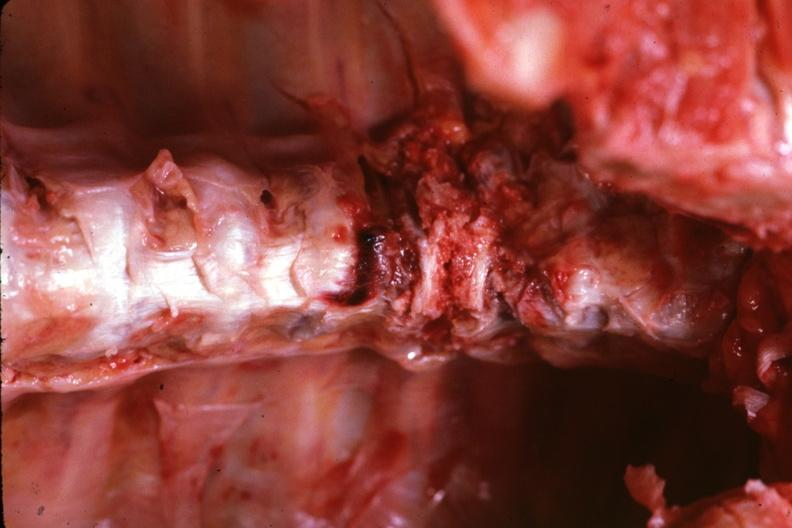what does this image show?
Answer the question using a single word or phrase. In situ close-up view very good lower cervical 